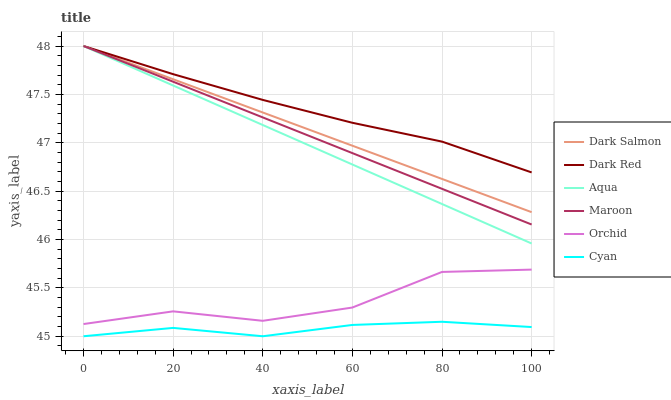Does Cyan have the minimum area under the curve?
Answer yes or no. Yes. Does Dark Red have the maximum area under the curve?
Answer yes or no. Yes. Does Aqua have the minimum area under the curve?
Answer yes or no. No. Does Aqua have the maximum area under the curve?
Answer yes or no. No. Is Dark Salmon the smoothest?
Answer yes or no. Yes. Is Orchid the roughest?
Answer yes or no. Yes. Is Aqua the smoothest?
Answer yes or no. No. Is Aqua the roughest?
Answer yes or no. No. Does Aqua have the lowest value?
Answer yes or no. No. Does Maroon have the highest value?
Answer yes or no. Yes. Does Cyan have the highest value?
Answer yes or no. No. Is Cyan less than Dark Red?
Answer yes or no. Yes. Is Aqua greater than Orchid?
Answer yes or no. Yes. Does Dark Red intersect Maroon?
Answer yes or no. Yes. Is Dark Red less than Maroon?
Answer yes or no. No. Is Dark Red greater than Maroon?
Answer yes or no. No. Does Cyan intersect Dark Red?
Answer yes or no. No. 